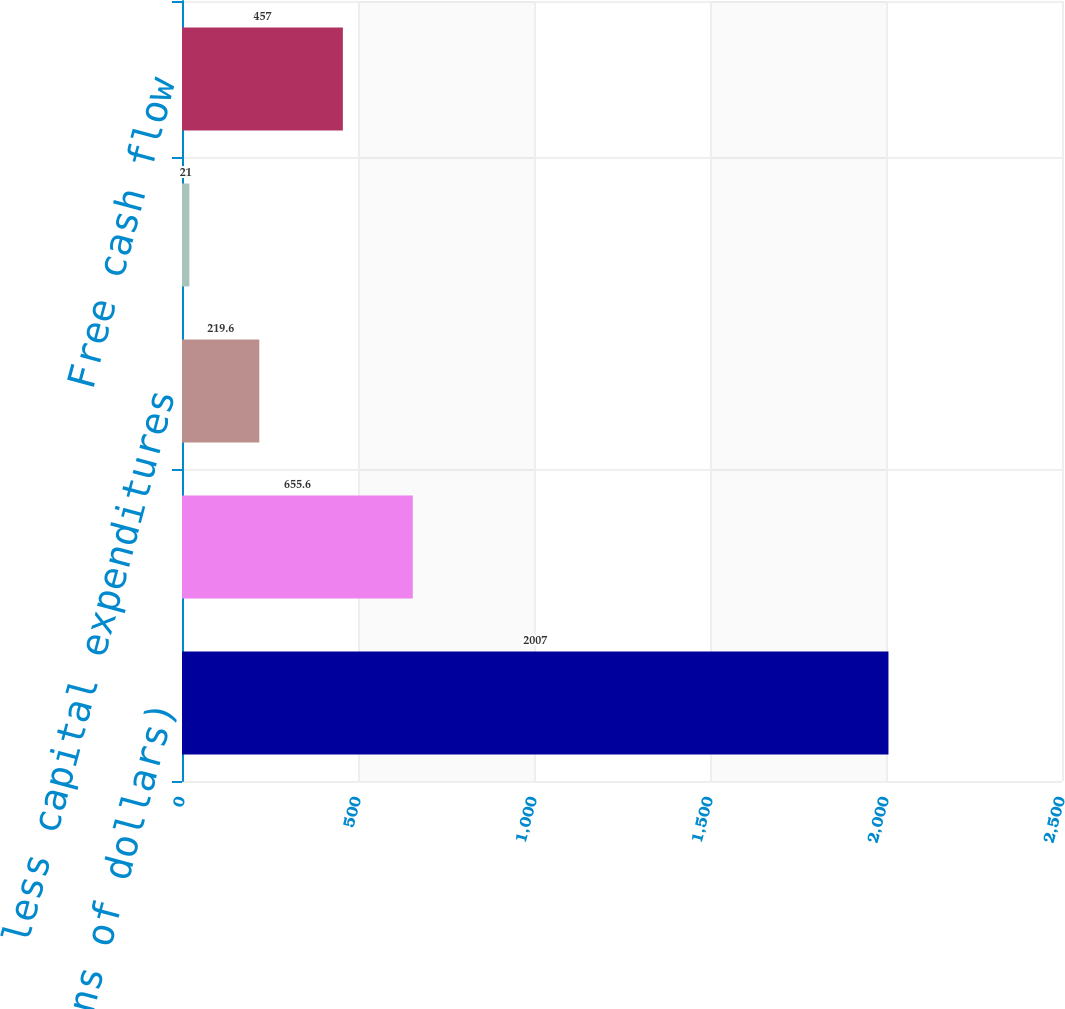Convert chart. <chart><loc_0><loc_0><loc_500><loc_500><bar_chart><fcel>(millions of dollars)<fcel>net cash provided by operating<fcel>less capital expenditures<fcel>less capitalized software<fcel>Free cash flow<nl><fcel>2007<fcel>655.6<fcel>219.6<fcel>21<fcel>457<nl></chart> 